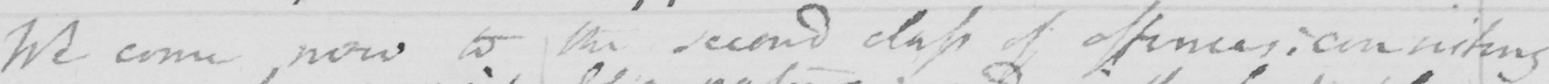What does this handwritten line say? We come now to the second class of offences :  consisting 